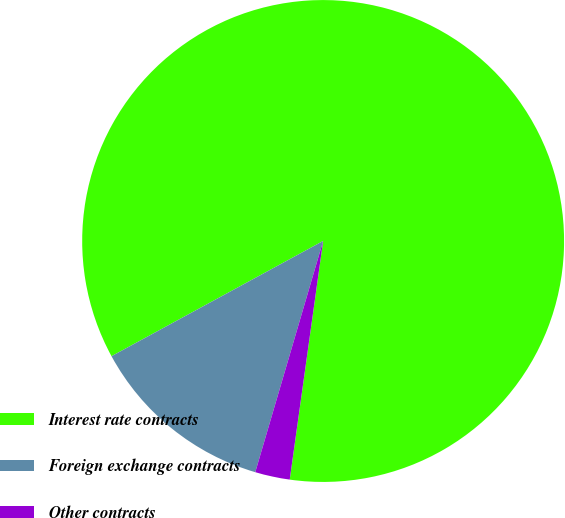Convert chart. <chart><loc_0><loc_0><loc_500><loc_500><pie_chart><fcel>Interest rate contracts<fcel>Foreign exchange contracts<fcel>Other contracts<nl><fcel>85.14%<fcel>12.52%<fcel>2.33%<nl></chart> 